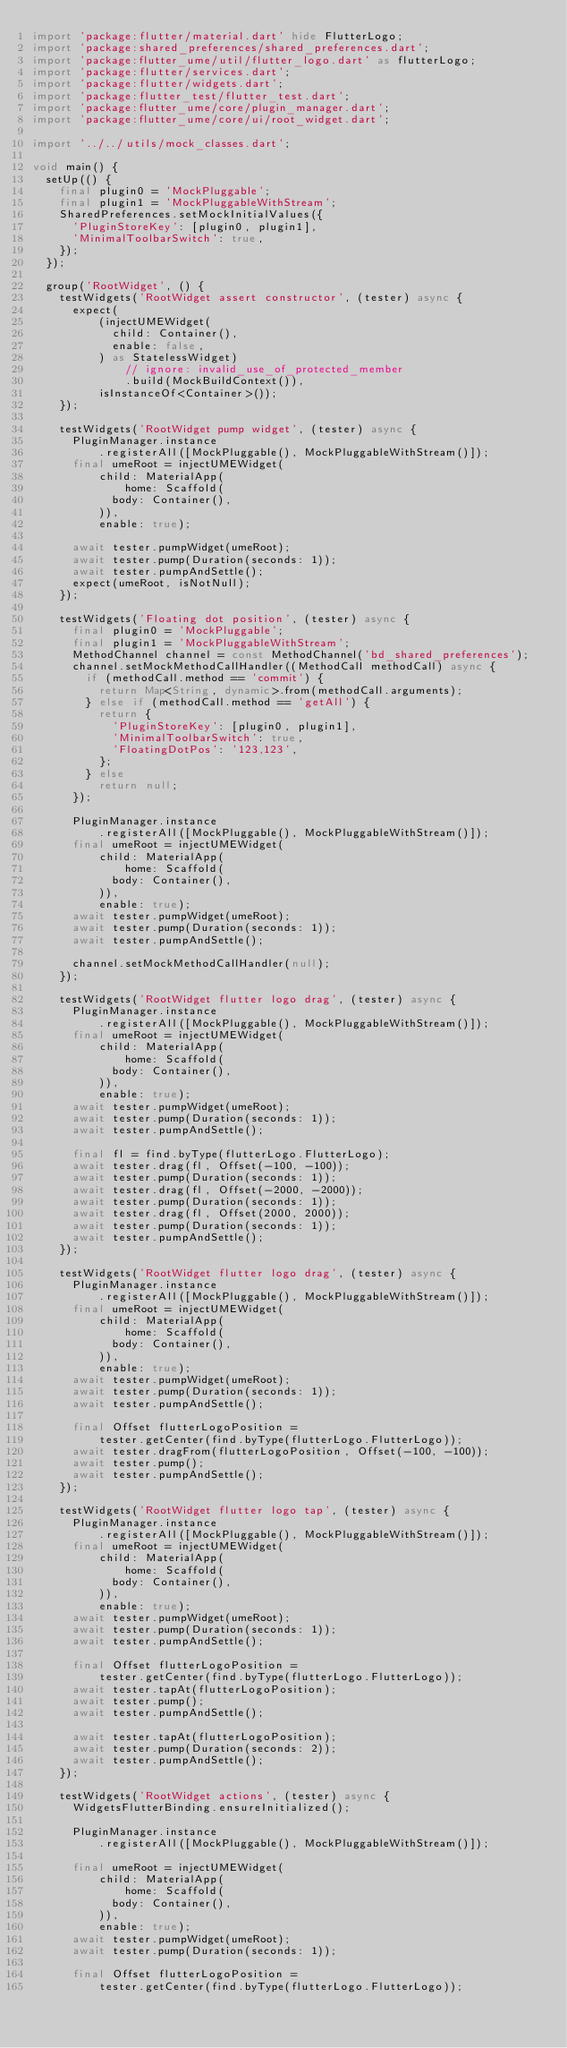<code> <loc_0><loc_0><loc_500><loc_500><_Dart_>import 'package:flutter/material.dart' hide FlutterLogo;
import 'package:shared_preferences/shared_preferences.dart';
import 'package:flutter_ume/util/flutter_logo.dart' as flutterLogo;
import 'package:flutter/services.dart';
import 'package:flutter/widgets.dart';
import 'package:flutter_test/flutter_test.dart';
import 'package:flutter_ume/core/plugin_manager.dart';
import 'package:flutter_ume/core/ui/root_widget.dart';

import '../../utils/mock_classes.dart';

void main() {
  setUp(() {
    final plugin0 = 'MockPluggable';
    final plugin1 = 'MockPluggableWithStream';
    SharedPreferences.setMockInitialValues({
      'PluginStoreKey': [plugin0, plugin1],
      'MinimalToolbarSwitch': true,
    });
  });

  group('RootWidget', () {
    testWidgets('RootWidget assert constructor', (tester) async {
      expect(
          (injectUMEWidget(
            child: Container(),
            enable: false,
          ) as StatelessWidget)
              // ignore: invalid_use_of_protected_member
              .build(MockBuildContext()),
          isInstanceOf<Container>());
    });

    testWidgets('RootWidget pump widget', (tester) async {
      PluginManager.instance
          .registerAll([MockPluggable(), MockPluggableWithStream()]);
      final umeRoot = injectUMEWidget(
          child: MaterialApp(
              home: Scaffold(
            body: Container(),
          )),
          enable: true);

      await tester.pumpWidget(umeRoot);
      await tester.pump(Duration(seconds: 1));
      await tester.pumpAndSettle();
      expect(umeRoot, isNotNull);
    });

    testWidgets('Floating dot position', (tester) async {
      final plugin0 = 'MockPluggable';
      final plugin1 = 'MockPluggableWithStream';
      MethodChannel channel = const MethodChannel('bd_shared_preferences');
      channel.setMockMethodCallHandler((MethodCall methodCall) async {
        if (methodCall.method == 'commit') {
          return Map<String, dynamic>.from(methodCall.arguments);
        } else if (methodCall.method == 'getAll') {
          return {
            'PluginStoreKey': [plugin0, plugin1],
            'MinimalToolbarSwitch': true,
            'FloatingDotPos': '123,123',
          };
        } else
          return null;
      });

      PluginManager.instance
          .registerAll([MockPluggable(), MockPluggableWithStream()]);
      final umeRoot = injectUMEWidget(
          child: MaterialApp(
              home: Scaffold(
            body: Container(),
          )),
          enable: true);
      await tester.pumpWidget(umeRoot);
      await tester.pump(Duration(seconds: 1));
      await tester.pumpAndSettle();

      channel.setMockMethodCallHandler(null);
    });

    testWidgets('RootWidget flutter logo drag', (tester) async {
      PluginManager.instance
          .registerAll([MockPluggable(), MockPluggableWithStream()]);
      final umeRoot = injectUMEWidget(
          child: MaterialApp(
              home: Scaffold(
            body: Container(),
          )),
          enable: true);
      await tester.pumpWidget(umeRoot);
      await tester.pump(Duration(seconds: 1));
      await tester.pumpAndSettle();

      final fl = find.byType(flutterLogo.FlutterLogo);
      await tester.drag(fl, Offset(-100, -100));
      await tester.pump(Duration(seconds: 1));
      await tester.drag(fl, Offset(-2000, -2000));
      await tester.pump(Duration(seconds: 1));
      await tester.drag(fl, Offset(2000, 2000));
      await tester.pump(Duration(seconds: 1));
      await tester.pumpAndSettle();
    });

    testWidgets('RootWidget flutter logo drag', (tester) async {
      PluginManager.instance
          .registerAll([MockPluggable(), MockPluggableWithStream()]);
      final umeRoot = injectUMEWidget(
          child: MaterialApp(
              home: Scaffold(
            body: Container(),
          )),
          enable: true);
      await tester.pumpWidget(umeRoot);
      await tester.pump(Duration(seconds: 1));
      await tester.pumpAndSettle();

      final Offset flutterLogoPosition =
          tester.getCenter(find.byType(flutterLogo.FlutterLogo));
      await tester.dragFrom(flutterLogoPosition, Offset(-100, -100));
      await tester.pump();
      await tester.pumpAndSettle();
    });

    testWidgets('RootWidget flutter logo tap', (tester) async {
      PluginManager.instance
          .registerAll([MockPluggable(), MockPluggableWithStream()]);
      final umeRoot = injectUMEWidget(
          child: MaterialApp(
              home: Scaffold(
            body: Container(),
          )),
          enable: true);
      await tester.pumpWidget(umeRoot);
      await tester.pump(Duration(seconds: 1));
      await tester.pumpAndSettle();

      final Offset flutterLogoPosition =
          tester.getCenter(find.byType(flutterLogo.FlutterLogo));
      await tester.tapAt(flutterLogoPosition);
      await tester.pump();
      await tester.pumpAndSettle();

      await tester.tapAt(flutterLogoPosition);
      await tester.pump(Duration(seconds: 2));
      await tester.pumpAndSettle();
    });

    testWidgets('RootWidget actions', (tester) async {
      WidgetsFlutterBinding.ensureInitialized();

      PluginManager.instance
          .registerAll([MockPluggable(), MockPluggableWithStream()]);

      final umeRoot = injectUMEWidget(
          child: MaterialApp(
              home: Scaffold(
            body: Container(),
          )),
          enable: true);
      await tester.pumpWidget(umeRoot);
      await tester.pump(Duration(seconds: 1));

      final Offset flutterLogoPosition =
          tester.getCenter(find.byType(flutterLogo.FlutterLogo));</code> 